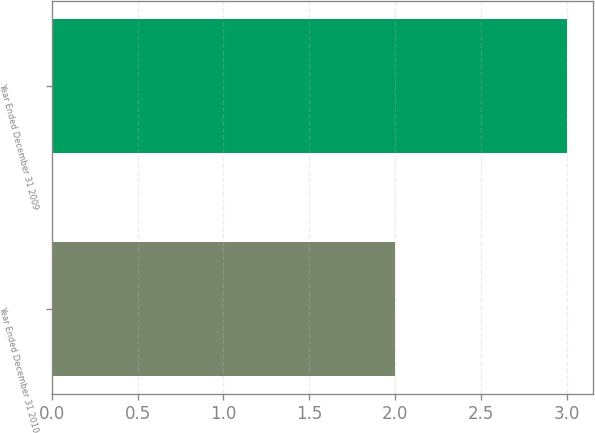<chart> <loc_0><loc_0><loc_500><loc_500><bar_chart><fcel>Year Ended December 31 2010<fcel>Year Ended December 31 2009<nl><fcel>2<fcel>3<nl></chart> 